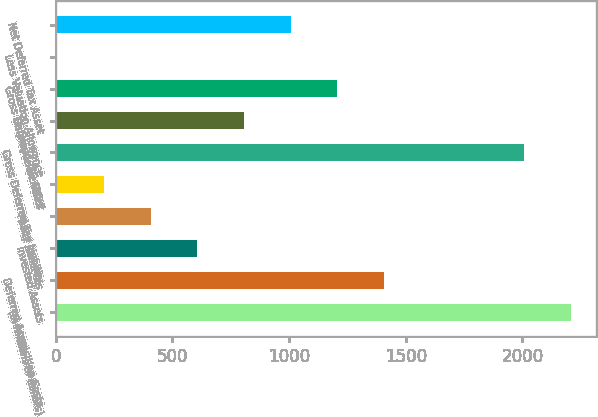Convert chart to OTSL. <chart><loc_0><loc_0><loc_500><loc_500><bar_chart><fcel>(in millions of dollars)<fcel>Deferred Acquisition Costs<fcel>Invested Assets<fcel>Policy Reserves<fcel>Other<fcel>Gross Deferred Tax Liability<fcel>Employee Benefits<fcel>Gross Deferred Tax Asset<fcel>Less Valuation Allowance<fcel>Net Deferred Tax Asset<nl><fcel>2205.96<fcel>1406.12<fcel>606.28<fcel>406.32<fcel>206.36<fcel>2006<fcel>806.24<fcel>1206.16<fcel>6.4<fcel>1006.2<nl></chart> 